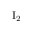Convert formula to latex. <formula><loc_0><loc_0><loc_500><loc_500>I _ { 2 }</formula> 